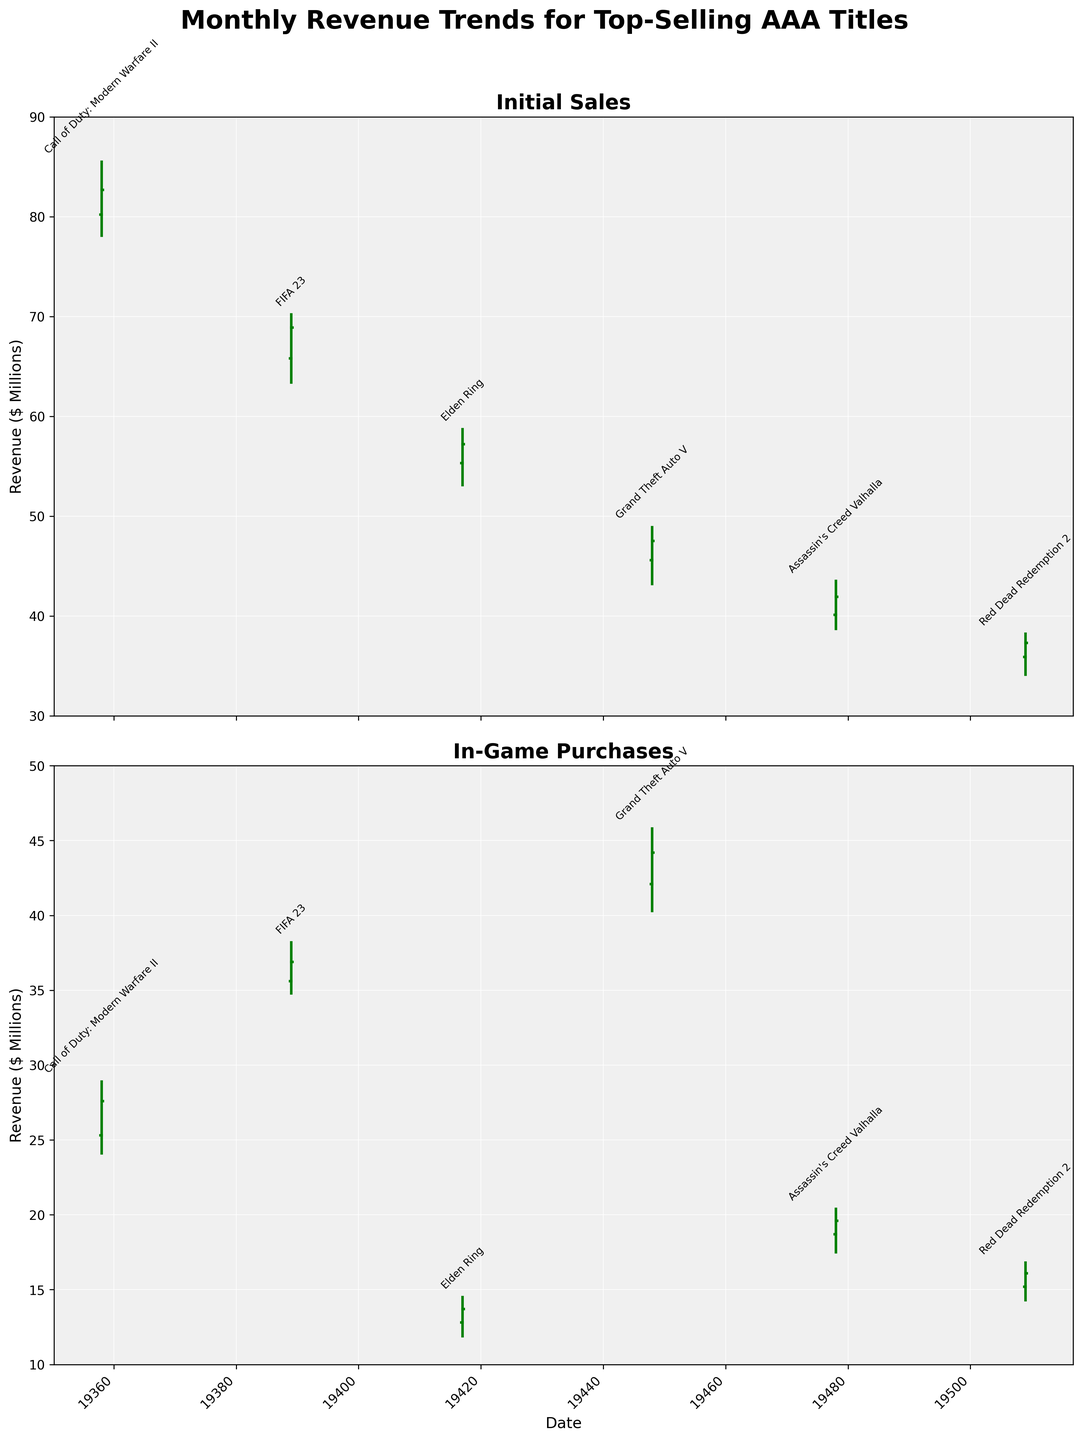what's the title of the figure? The title is located at the top of the figure. It summarizes the subject of the chart.
Answer: Monthly Revenue Trends for Top-Selling AAA Titles What is the time period covered in the chart? The x-axis represents the date and indicates the specific months included in the dataset. From this, we can determine the time period covered. The months are from January 2023 to June 2023.
Answer: January 2023 to June 2023 Which game had the highest initial sales high point, and what was the value? By examining the "Initial Sales" OHLC chart, we look for the highest point reached on the y-axis within the "High" values. "Call of Duty: Modern Warfare II" in January 2023 had the highest value at 85.5.
Answer: Call of Duty: Modern Warfare II, 85.5 How does the revenue from in-game purchases generally compare to initial sales? We can visually compare the range of values on the y-axes of both subplots. The y-axis for "Initial Sales" ranges higher (up to 90) compared to the "In-Game Purchases" (up to 50). This shows that the revenue from initial sales is generally higher than that from in-game purchases.
Answer: Initial sales are generally higher Which game had the most significant drop in initial sales from open to close, and what was the amount? To find the most significant drop, look at the difference between the open and close values in the "Initial Sales" OHLC chart. "Call of Duty: Modern Warfare II" dropped from 80.2 to 82.7, a drop of 2.5.
Answer: Call of Duty: Modern Warfare II, 2.5 What month shows the highest in-game purchases high value, and what was the title of the game? By examining the "In-Game Purchases" OHLC chart, the highest "High" value is noted. The highest "High" value, 45.8, appears in April 2023 for "Grand Theft Auto V".
Answer: April 2023, Grand Theft Auto V Which month had the smallest range in initial sales and what was the range? For each month, subtract the "Low" value from the "High" value in the "Initial Sales" OHLC chart. The smallest range appears for "Red Dead Redemption 2" in June 2023, with a range of 38.2 - 34.1 = 4.1.
Answer: June 2023, 4.1 Which game had the highest closing value for in-game purchases, and what was the value? Examine the "In-Game Purchases" OHLC chart and identify the highest value among the "Close" values. The highest closing value is 44.2, corresponding to "Grand Theft Auto V" in April 2023.
Answer: Grand Theft Auto V, 44.2 For "Elden Ring" in March 2023, compare the closing values of initial sales and in-game purchases. Identify the closing values for both types of sales for "Elden Ring" in March 2023. "Initial Sales" close at 57.2, and "In-Game Purchases" close at 13.7. Thus, initial sales are higher.
Answer: Initial sales: 57.2, In-game purchases: 13.7 Is there any game where initial sales and in-game purchases close at the same value in any month? By inspection of closing values in both charts, we look for any month where the closing values match. There is no instance where initial sales and in-game purchases close at the same value.
Answer: No 